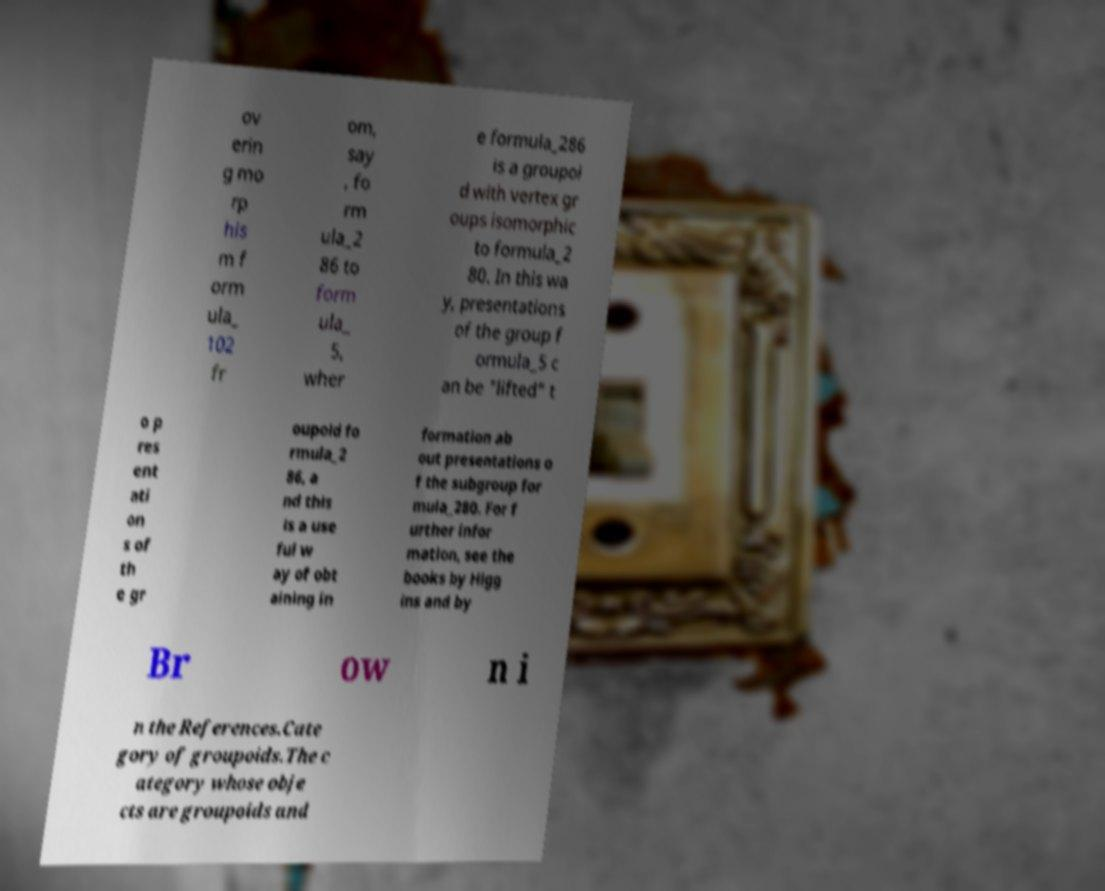Could you extract and type out the text from this image? ov erin g mo rp his m f orm ula_ 102 fr om, say , fo rm ula_2 86 to form ula_ 5, wher e formula_286 is a groupoi d with vertex gr oups isomorphic to formula_2 80. In this wa y, presentations of the group f ormula_5 c an be "lifted" t o p res ent ati on s of th e gr oupoid fo rmula_2 86, a nd this is a use ful w ay of obt aining in formation ab out presentations o f the subgroup for mula_280. For f urther infor mation, see the books by Higg ins and by Br ow n i n the References.Cate gory of groupoids.The c ategory whose obje cts are groupoids and 